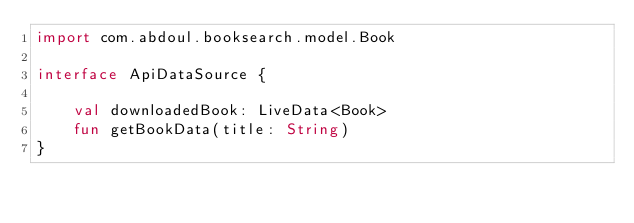Convert code to text. <code><loc_0><loc_0><loc_500><loc_500><_Kotlin_>import com.abdoul.booksearch.model.Book

interface ApiDataSource {

    val downloadedBook: LiveData<Book>
    fun getBookData(title: String)
}</code> 